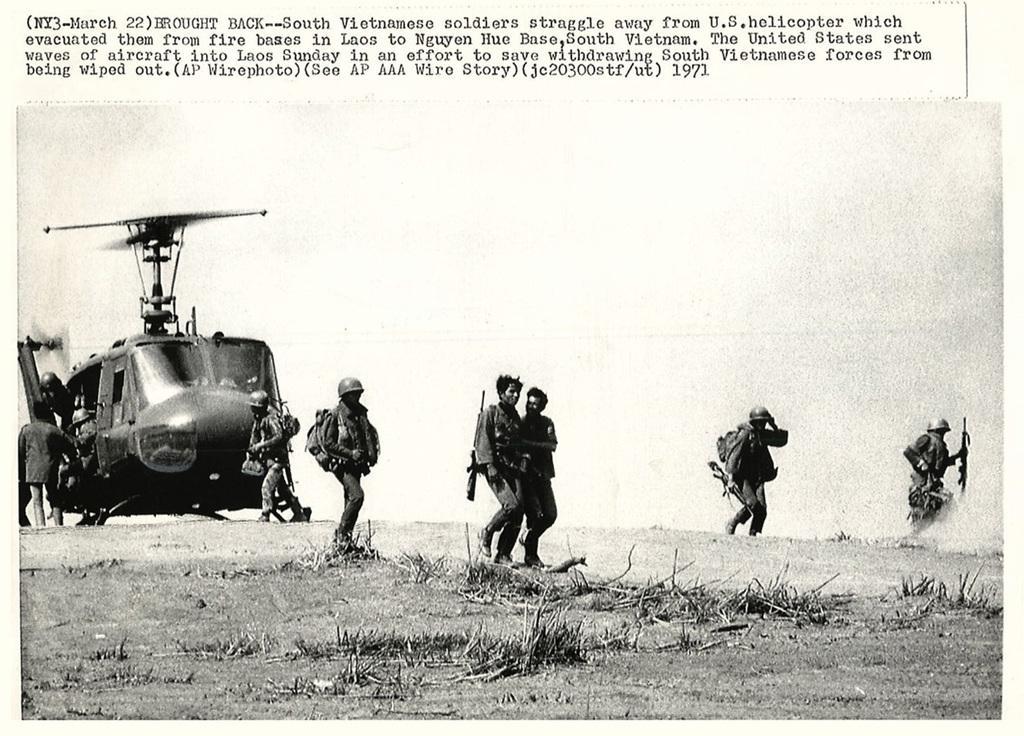In one or two sentences, can you explain what this image depicts? In this picture, it looks like a paper with an image. In the image, we can see people, a helicopter and grass. At the top of the picture, it is written something. 